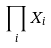Convert formula to latex. <formula><loc_0><loc_0><loc_500><loc_500>\prod _ { i } X _ { i }</formula> 